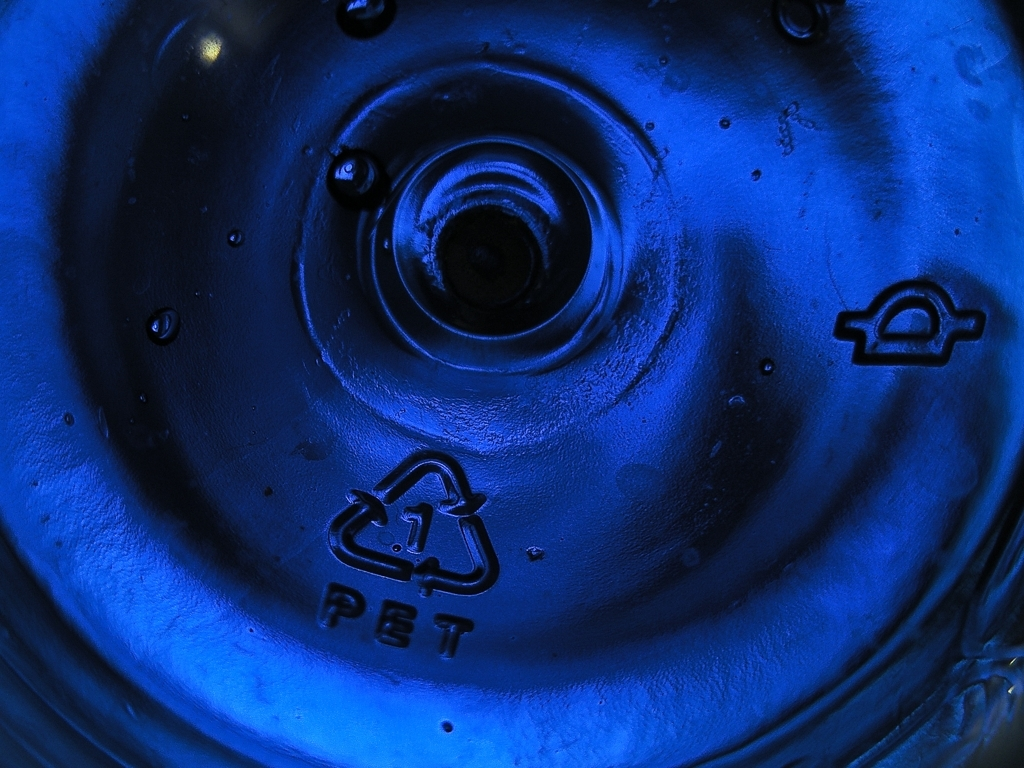Are there any noticeable artifacts in the image? No noticeable artifacts are present in the image, appearing free from distortion or unintended marks. The blue color of the object is consistent, and both the lighting and the resolution seem appropriate for capturing the details clearly. 